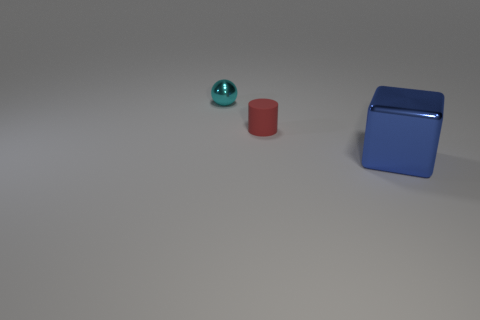Add 2 cyan objects. How many objects exist? 5 Subtract all cubes. How many objects are left? 2 Subtract all tiny cyan spheres. Subtract all blue cubes. How many objects are left? 1 Add 1 shiny blocks. How many shiny blocks are left? 2 Add 1 large yellow shiny spheres. How many large yellow shiny spheres exist? 1 Subtract 0 gray balls. How many objects are left? 3 